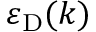Convert formula to latex. <formula><loc_0><loc_0><loc_500><loc_500>\varepsilon _ { D } ( k )</formula> 